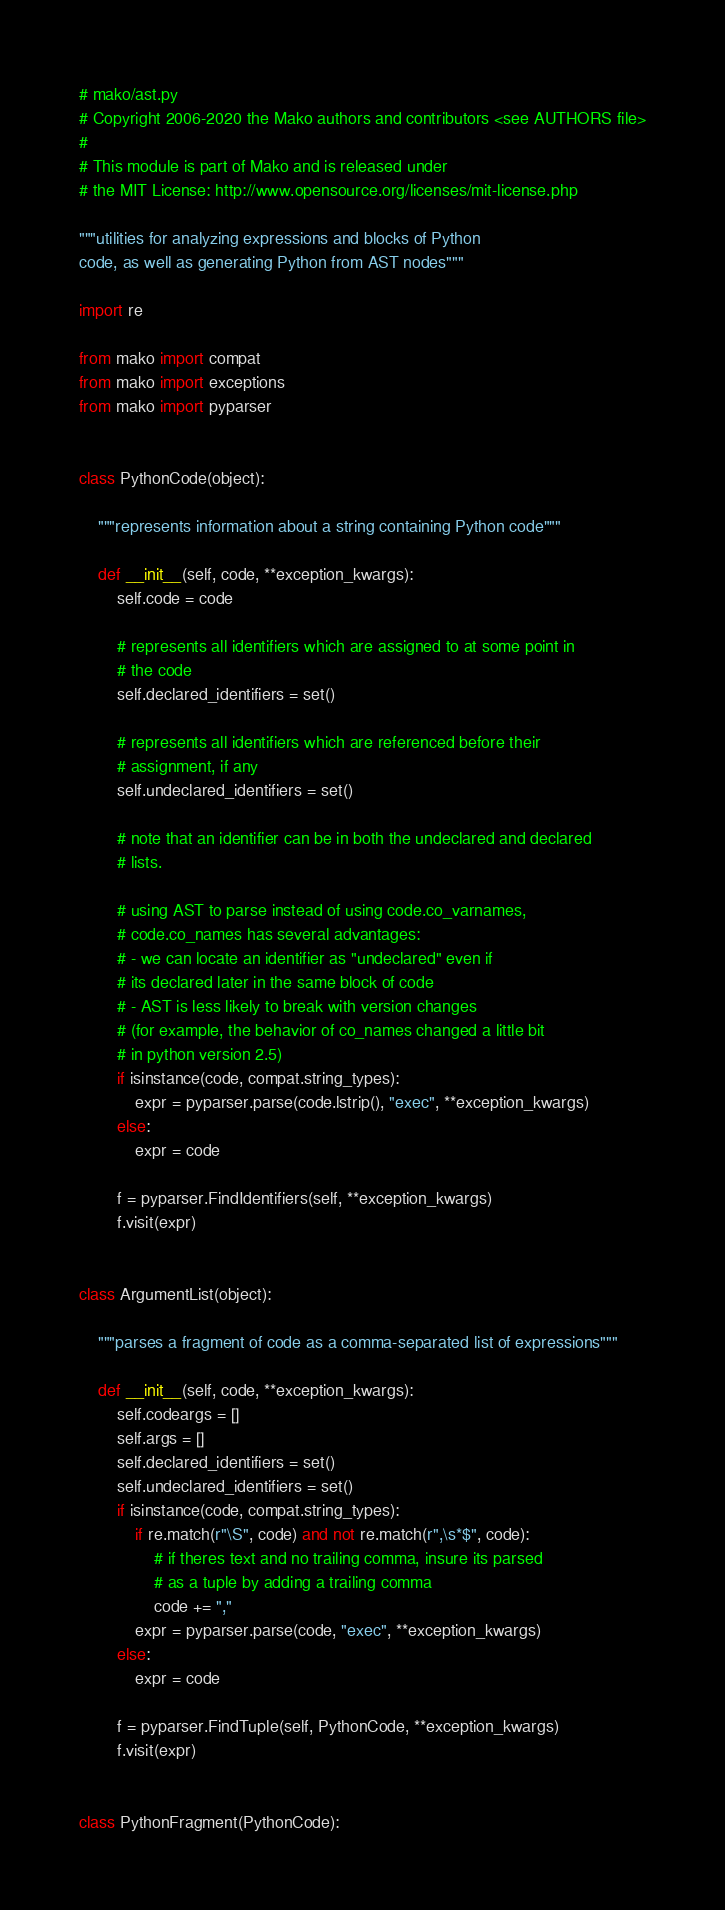Convert code to text. <code><loc_0><loc_0><loc_500><loc_500><_Python_># mako/ast.py
# Copyright 2006-2020 the Mako authors and contributors <see AUTHORS file>
#
# This module is part of Mako and is released under
# the MIT License: http://www.opensource.org/licenses/mit-license.php

"""utilities for analyzing expressions and blocks of Python
code, as well as generating Python from AST nodes"""

import re

from mako import compat
from mako import exceptions
from mako import pyparser


class PythonCode(object):

    """represents information about a string containing Python code"""

    def __init__(self, code, **exception_kwargs):
        self.code = code

        # represents all identifiers which are assigned to at some point in
        # the code
        self.declared_identifiers = set()

        # represents all identifiers which are referenced before their
        # assignment, if any
        self.undeclared_identifiers = set()

        # note that an identifier can be in both the undeclared and declared
        # lists.

        # using AST to parse instead of using code.co_varnames,
        # code.co_names has several advantages:
        # - we can locate an identifier as "undeclared" even if
        # its declared later in the same block of code
        # - AST is less likely to break with version changes
        # (for example, the behavior of co_names changed a little bit
        # in python version 2.5)
        if isinstance(code, compat.string_types):
            expr = pyparser.parse(code.lstrip(), "exec", **exception_kwargs)
        else:
            expr = code

        f = pyparser.FindIdentifiers(self, **exception_kwargs)
        f.visit(expr)


class ArgumentList(object):

    """parses a fragment of code as a comma-separated list of expressions"""

    def __init__(self, code, **exception_kwargs):
        self.codeargs = []
        self.args = []
        self.declared_identifiers = set()
        self.undeclared_identifiers = set()
        if isinstance(code, compat.string_types):
            if re.match(r"\S", code) and not re.match(r",\s*$", code):
                # if theres text and no trailing comma, insure its parsed
                # as a tuple by adding a trailing comma
                code += ","
            expr = pyparser.parse(code, "exec", **exception_kwargs)
        else:
            expr = code

        f = pyparser.FindTuple(self, PythonCode, **exception_kwargs)
        f.visit(expr)


class PythonFragment(PythonCode):
</code> 